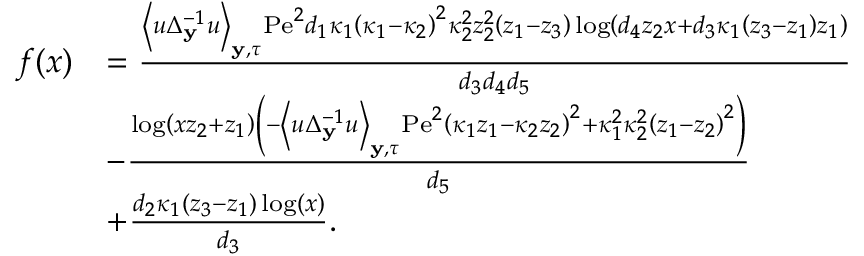<formula> <loc_0><loc_0><loc_500><loc_500>\begin{array} { r l } { f ( x ) } & { = \frac { \left \langle u \Delta _ { y } ^ { - 1 } u \right \rangle _ { y , \tau } P e ^ { 2 } d _ { 1 } \kappa _ { 1 } \left ( \kappa _ { 1 } - \kappa _ { 2 } \right ) ^ { 2 } \kappa _ { 2 } ^ { 2 } z _ { 2 } ^ { 2 } \left ( z _ { 1 } - z _ { 3 } \right ) \log \left ( d _ { 4 } z _ { 2 } x + d _ { 3 } \kappa _ { 1 } \left ( z _ { 3 } - z _ { 1 } \right ) z _ { 1 } \right ) } { d _ { 3 } d _ { 4 } d _ { 5 } } } \\ & { - \frac { \log \left ( x z _ { 2 } + z _ { 1 } \right ) \left ( - \left \langle u \Delta _ { y } ^ { - 1 } u \right \rangle _ { y , \tau } P e ^ { 2 } \left ( \kappa _ { 1 } z _ { 1 } - \kappa _ { 2 } z _ { 2 } \right ) ^ { 2 } + \kappa _ { 1 } ^ { 2 } \kappa _ { 2 } ^ { 2 } \left ( z _ { 1 } - z _ { 2 } \right ) ^ { 2 } \right ) } { d _ { 5 } } } \\ & { + \frac { d _ { 2 } \kappa _ { 1 } \left ( z _ { 3 } - z _ { 1 } \right ) \log ( x ) } { d _ { 3 } } . } \end{array}</formula> 